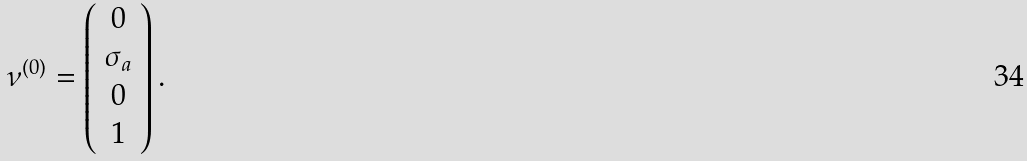Convert formula to latex. <formula><loc_0><loc_0><loc_500><loc_500>\nu ^ { ( 0 ) } = \left ( \begin{array} { c c c } { 0 } \\ { { \sigma _ { a } } } \\ { 0 } \\ { 1 } \end{array} \right ) .</formula> 